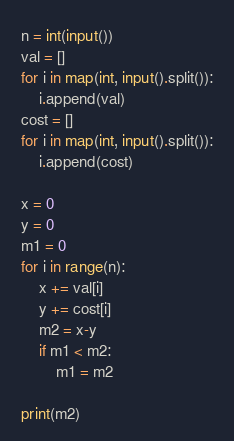Convert code to text. <code><loc_0><loc_0><loc_500><loc_500><_Python_>n = int(input())
val = []
for i in map(int, input().split()):
    i.append(val)
cost = []
for i in map(int, input().split()):
    i.append(cost)

x = 0
y = 0
m1 = 0
for i in range(n):
    x += val[i]
    y += cost[i]
    m2 = x-y
    if m1 < m2:
        m1 = m2

print(m2)
</code> 